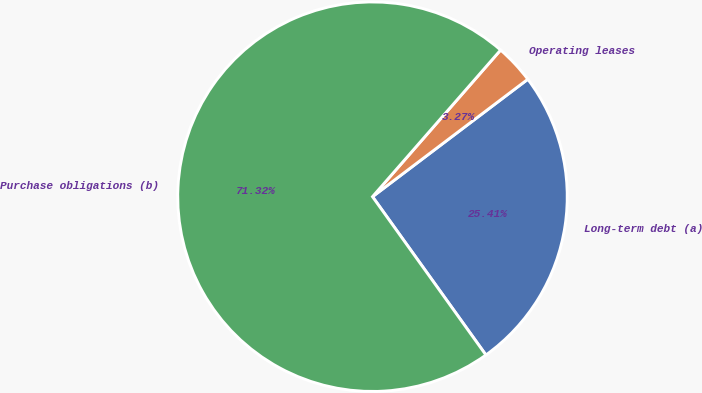Convert chart to OTSL. <chart><loc_0><loc_0><loc_500><loc_500><pie_chart><fcel>Long-term debt (a)<fcel>Operating leases<fcel>Purchase obligations (b)<nl><fcel>25.41%<fcel>3.27%<fcel>71.32%<nl></chart> 